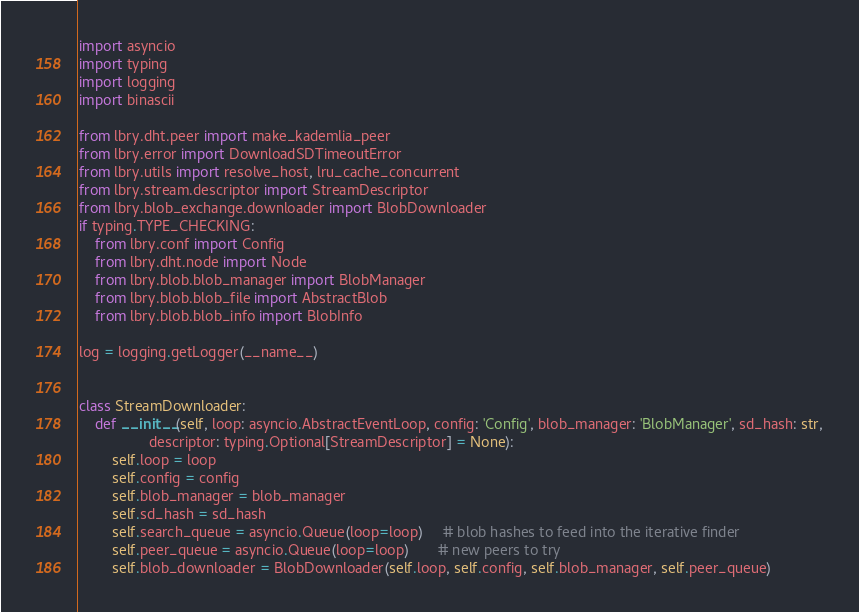<code> <loc_0><loc_0><loc_500><loc_500><_Python_>import asyncio
import typing
import logging
import binascii

from lbry.dht.peer import make_kademlia_peer
from lbry.error import DownloadSDTimeoutError
from lbry.utils import resolve_host, lru_cache_concurrent
from lbry.stream.descriptor import StreamDescriptor
from lbry.blob_exchange.downloader import BlobDownloader
if typing.TYPE_CHECKING:
    from lbry.conf import Config
    from lbry.dht.node import Node
    from lbry.blob.blob_manager import BlobManager
    from lbry.blob.blob_file import AbstractBlob
    from lbry.blob.blob_info import BlobInfo

log = logging.getLogger(__name__)


class StreamDownloader:
    def __init__(self, loop: asyncio.AbstractEventLoop, config: 'Config', blob_manager: 'BlobManager', sd_hash: str,
                 descriptor: typing.Optional[StreamDescriptor] = None):
        self.loop = loop
        self.config = config
        self.blob_manager = blob_manager
        self.sd_hash = sd_hash
        self.search_queue = asyncio.Queue(loop=loop)     # blob hashes to feed into the iterative finder
        self.peer_queue = asyncio.Queue(loop=loop)       # new peers to try
        self.blob_downloader = BlobDownloader(self.loop, self.config, self.blob_manager, self.peer_queue)</code> 